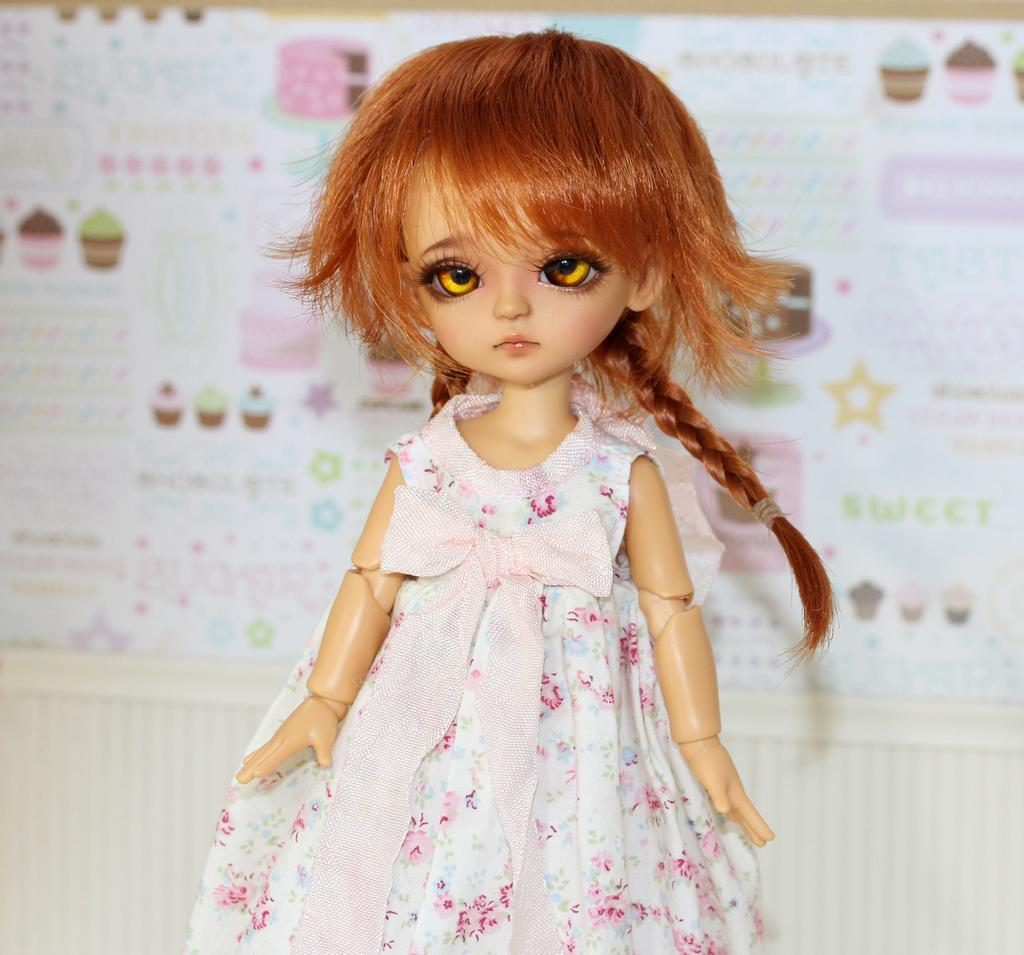What is the main subject of the image? There is a doll in the image. What is the doll wearing? The doll is wearing a white and pink color dress. What color are the doll's eyes? The doll has brown eyes. What color is the doll's hair? The doll has brown hair. What can be seen in the background of the image? There is a chart in the background of the image. What type of animals can be seen at the zoo in the image? There is no zoo present in the image; it features a doll with a chart in the background. What mathematical operation is being performed on the chart in the image? The image does not show any mathematical operations being performed on the chart. 